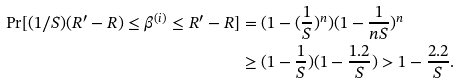Convert formula to latex. <formula><loc_0><loc_0><loc_500><loc_500>\Pr [ ( 1 / S ) ( R ^ { \prime } - R ) \leq \beta ^ { ( i ) } \leq R ^ { \prime } - R ] & = ( 1 - ( \frac { 1 } { S } ) ^ { n } ) ( 1 - \frac { 1 } { n S } ) ^ { n } \\ & \geq ( 1 - \frac { 1 } { S } ) ( 1 - \frac { 1 . 2 } { S } ) > 1 - \frac { 2 . 2 } { S } .</formula> 